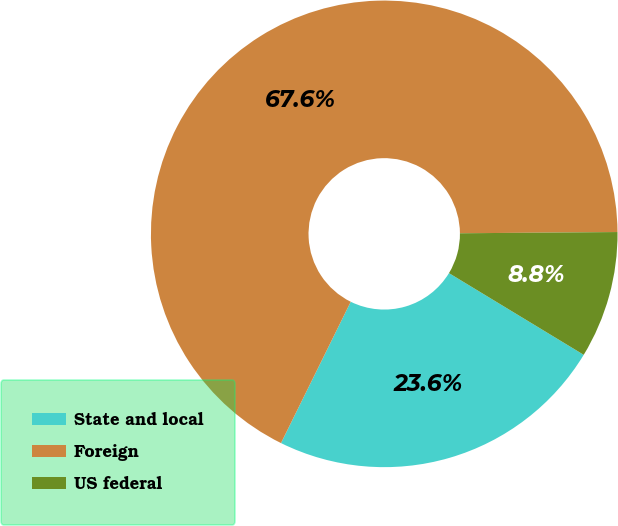Convert chart to OTSL. <chart><loc_0><loc_0><loc_500><loc_500><pie_chart><fcel>State and local<fcel>Foreign<fcel>US federal<nl><fcel>23.62%<fcel>67.58%<fcel>8.8%<nl></chart> 